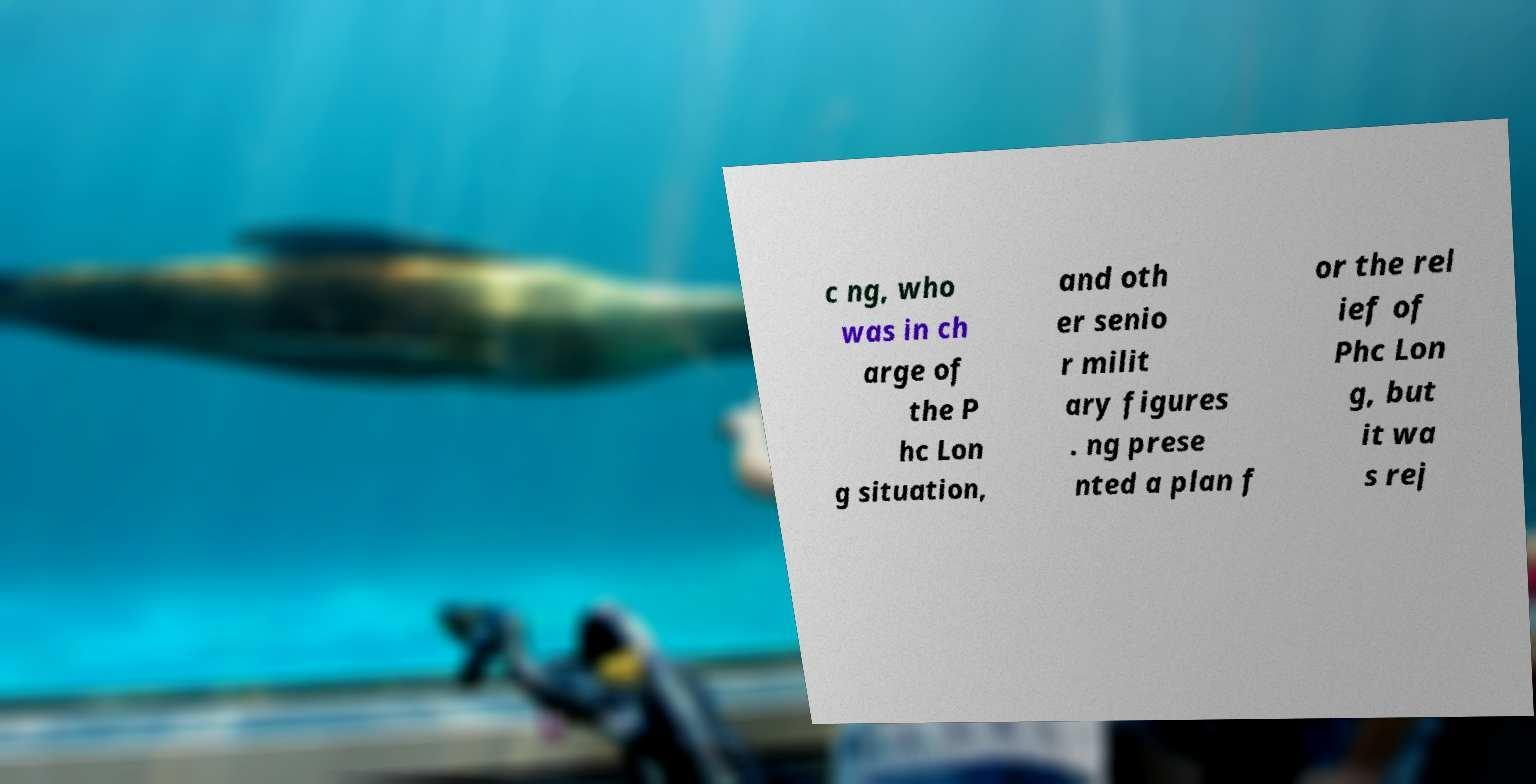There's text embedded in this image that I need extracted. Can you transcribe it verbatim? c ng, who was in ch arge of the P hc Lon g situation, and oth er senio r milit ary figures . ng prese nted a plan f or the rel ief of Phc Lon g, but it wa s rej 